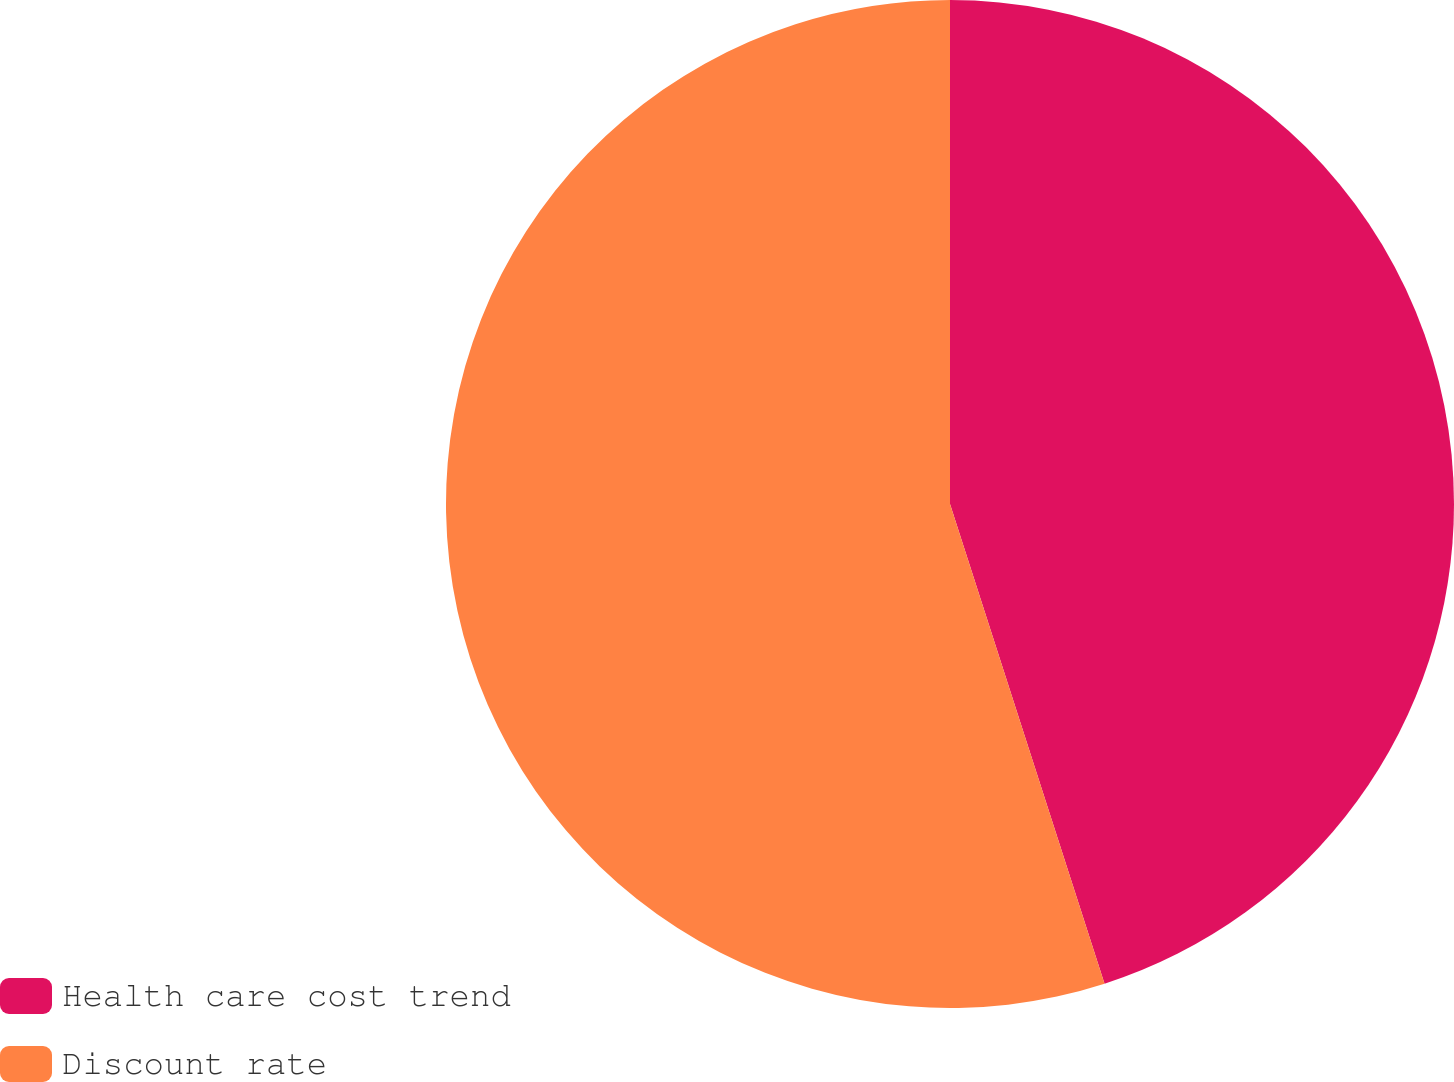Convert chart. <chart><loc_0><loc_0><loc_500><loc_500><pie_chart><fcel>Health care cost trend<fcel>Discount rate<nl><fcel>45.04%<fcel>54.96%<nl></chart> 